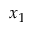Convert formula to latex. <formula><loc_0><loc_0><loc_500><loc_500>x _ { 1 }</formula> 